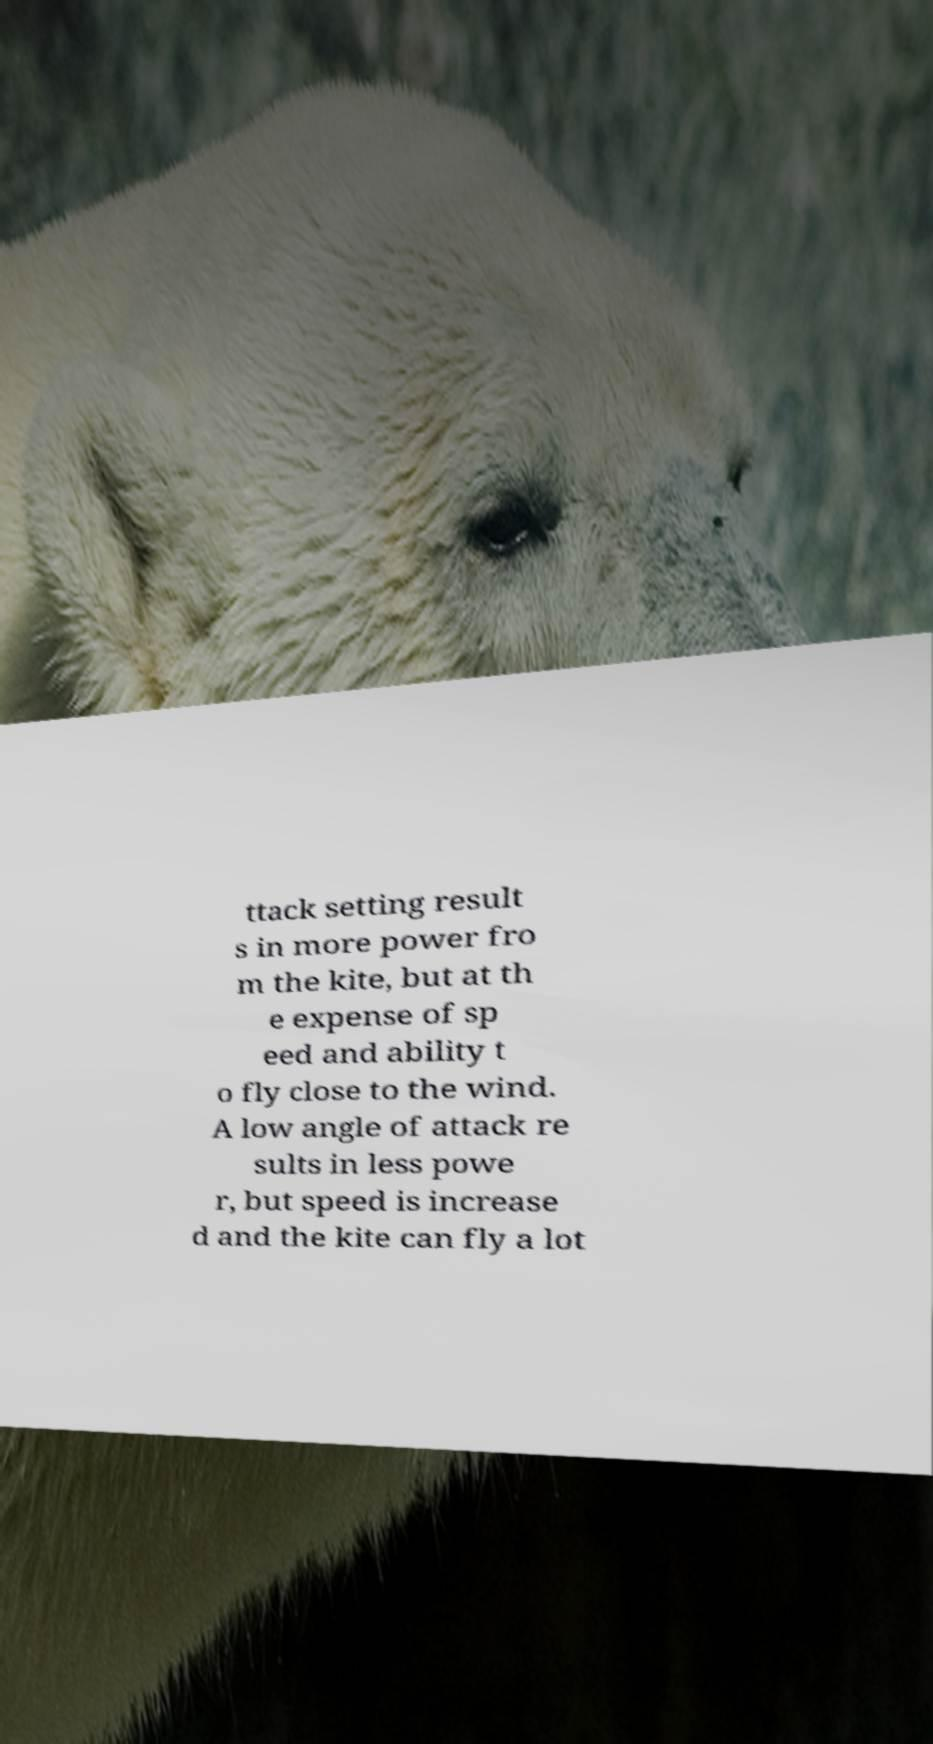Could you extract and type out the text from this image? ttack setting result s in more power fro m the kite, but at th e expense of sp eed and ability t o fly close to the wind. A low angle of attack re sults in less powe r, but speed is increase d and the kite can fly a lot 